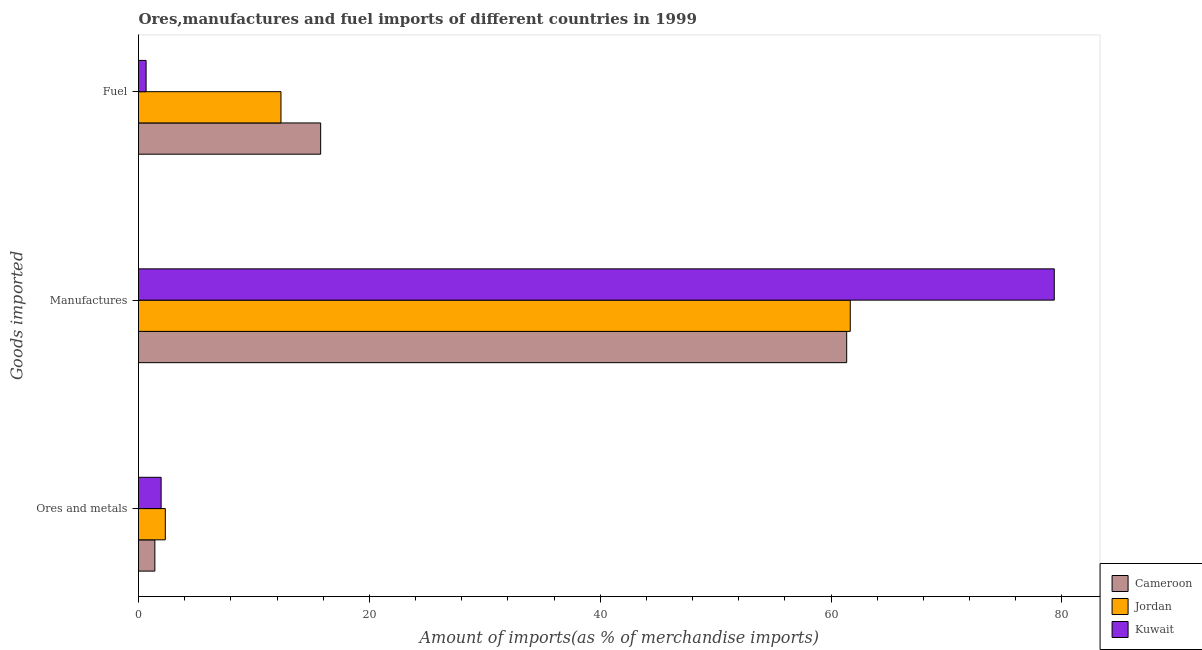How many different coloured bars are there?
Make the answer very short. 3. How many groups of bars are there?
Your answer should be compact. 3. Are the number of bars on each tick of the Y-axis equal?
Give a very brief answer. Yes. How many bars are there on the 3rd tick from the top?
Offer a terse response. 3. What is the label of the 1st group of bars from the top?
Your answer should be very brief. Fuel. What is the percentage of manufactures imports in Kuwait?
Your answer should be compact. 79.33. Across all countries, what is the maximum percentage of ores and metals imports?
Offer a very short reply. 2.32. Across all countries, what is the minimum percentage of fuel imports?
Your answer should be very brief. 0.66. In which country was the percentage of fuel imports maximum?
Your response must be concise. Cameroon. In which country was the percentage of ores and metals imports minimum?
Give a very brief answer. Cameroon. What is the total percentage of fuel imports in the graph?
Ensure brevity in your answer.  28.78. What is the difference between the percentage of manufactures imports in Cameroon and that in Kuwait?
Provide a short and direct response. -17.98. What is the difference between the percentage of manufactures imports in Cameroon and the percentage of fuel imports in Jordan?
Your answer should be compact. 49.01. What is the average percentage of ores and metals imports per country?
Your response must be concise. 1.9. What is the difference between the percentage of ores and metals imports and percentage of fuel imports in Cameroon?
Your answer should be compact. -14.36. In how many countries, is the percentage of fuel imports greater than 24 %?
Your answer should be very brief. 0. What is the ratio of the percentage of manufactures imports in Kuwait to that in Cameroon?
Your answer should be very brief. 1.29. Is the difference between the percentage of ores and metals imports in Jordan and Kuwait greater than the difference between the percentage of manufactures imports in Jordan and Kuwait?
Make the answer very short. Yes. What is the difference between the highest and the second highest percentage of manufactures imports?
Make the answer very short. 17.67. What is the difference between the highest and the lowest percentage of fuel imports?
Your response must be concise. 15.12. In how many countries, is the percentage of manufactures imports greater than the average percentage of manufactures imports taken over all countries?
Your answer should be very brief. 1. Is the sum of the percentage of fuel imports in Cameroon and Jordan greater than the maximum percentage of ores and metals imports across all countries?
Ensure brevity in your answer.  Yes. What does the 1st bar from the top in Manufactures represents?
Ensure brevity in your answer.  Kuwait. What does the 1st bar from the bottom in Ores and metals represents?
Your response must be concise. Cameroon. Does the graph contain any zero values?
Ensure brevity in your answer.  No. Where does the legend appear in the graph?
Ensure brevity in your answer.  Bottom right. How are the legend labels stacked?
Provide a succinct answer. Vertical. What is the title of the graph?
Offer a very short reply. Ores,manufactures and fuel imports of different countries in 1999. Does "Finland" appear as one of the legend labels in the graph?
Your response must be concise. No. What is the label or title of the X-axis?
Provide a short and direct response. Amount of imports(as % of merchandise imports). What is the label or title of the Y-axis?
Ensure brevity in your answer.  Goods imported. What is the Amount of imports(as % of merchandise imports) in Cameroon in Ores and metals?
Provide a succinct answer. 1.42. What is the Amount of imports(as % of merchandise imports) in Jordan in Ores and metals?
Give a very brief answer. 2.32. What is the Amount of imports(as % of merchandise imports) in Kuwait in Ores and metals?
Offer a very short reply. 1.96. What is the Amount of imports(as % of merchandise imports) in Cameroon in Manufactures?
Your answer should be compact. 61.35. What is the Amount of imports(as % of merchandise imports) in Jordan in Manufactures?
Offer a very short reply. 61.66. What is the Amount of imports(as % of merchandise imports) of Kuwait in Manufactures?
Make the answer very short. 79.33. What is the Amount of imports(as % of merchandise imports) of Cameroon in Fuel?
Provide a short and direct response. 15.78. What is the Amount of imports(as % of merchandise imports) of Jordan in Fuel?
Offer a very short reply. 12.34. What is the Amount of imports(as % of merchandise imports) in Kuwait in Fuel?
Make the answer very short. 0.66. Across all Goods imported, what is the maximum Amount of imports(as % of merchandise imports) in Cameroon?
Make the answer very short. 61.35. Across all Goods imported, what is the maximum Amount of imports(as % of merchandise imports) of Jordan?
Provide a short and direct response. 61.66. Across all Goods imported, what is the maximum Amount of imports(as % of merchandise imports) of Kuwait?
Your answer should be very brief. 79.33. Across all Goods imported, what is the minimum Amount of imports(as % of merchandise imports) in Cameroon?
Give a very brief answer. 1.42. Across all Goods imported, what is the minimum Amount of imports(as % of merchandise imports) of Jordan?
Provide a succinct answer. 2.32. Across all Goods imported, what is the minimum Amount of imports(as % of merchandise imports) of Kuwait?
Provide a short and direct response. 0.66. What is the total Amount of imports(as % of merchandise imports) in Cameroon in the graph?
Your answer should be very brief. 78.55. What is the total Amount of imports(as % of merchandise imports) of Jordan in the graph?
Ensure brevity in your answer.  76.33. What is the total Amount of imports(as % of merchandise imports) of Kuwait in the graph?
Give a very brief answer. 81.95. What is the difference between the Amount of imports(as % of merchandise imports) of Cameroon in Ores and metals and that in Manufactures?
Give a very brief answer. -59.93. What is the difference between the Amount of imports(as % of merchandise imports) in Jordan in Ores and metals and that in Manufactures?
Offer a very short reply. -59.34. What is the difference between the Amount of imports(as % of merchandise imports) of Kuwait in Ores and metals and that in Manufactures?
Your answer should be compact. -77.38. What is the difference between the Amount of imports(as % of merchandise imports) in Cameroon in Ores and metals and that in Fuel?
Ensure brevity in your answer.  -14.36. What is the difference between the Amount of imports(as % of merchandise imports) in Jordan in Ores and metals and that in Fuel?
Your answer should be very brief. -10.02. What is the difference between the Amount of imports(as % of merchandise imports) of Kuwait in Ores and metals and that in Fuel?
Your response must be concise. 1.3. What is the difference between the Amount of imports(as % of merchandise imports) in Cameroon in Manufactures and that in Fuel?
Offer a very short reply. 45.57. What is the difference between the Amount of imports(as % of merchandise imports) of Jordan in Manufactures and that in Fuel?
Ensure brevity in your answer.  49.32. What is the difference between the Amount of imports(as % of merchandise imports) of Kuwait in Manufactures and that in Fuel?
Your answer should be compact. 78.68. What is the difference between the Amount of imports(as % of merchandise imports) in Cameroon in Ores and metals and the Amount of imports(as % of merchandise imports) in Jordan in Manufactures?
Keep it short and to the point. -60.24. What is the difference between the Amount of imports(as % of merchandise imports) in Cameroon in Ores and metals and the Amount of imports(as % of merchandise imports) in Kuwait in Manufactures?
Provide a short and direct response. -77.92. What is the difference between the Amount of imports(as % of merchandise imports) of Jordan in Ores and metals and the Amount of imports(as % of merchandise imports) of Kuwait in Manufactures?
Your answer should be compact. -77.01. What is the difference between the Amount of imports(as % of merchandise imports) of Cameroon in Ores and metals and the Amount of imports(as % of merchandise imports) of Jordan in Fuel?
Ensure brevity in your answer.  -10.93. What is the difference between the Amount of imports(as % of merchandise imports) of Cameroon in Ores and metals and the Amount of imports(as % of merchandise imports) of Kuwait in Fuel?
Your answer should be compact. 0.76. What is the difference between the Amount of imports(as % of merchandise imports) in Jordan in Ores and metals and the Amount of imports(as % of merchandise imports) in Kuwait in Fuel?
Keep it short and to the point. 1.66. What is the difference between the Amount of imports(as % of merchandise imports) of Cameroon in Manufactures and the Amount of imports(as % of merchandise imports) of Jordan in Fuel?
Your answer should be compact. 49.01. What is the difference between the Amount of imports(as % of merchandise imports) of Cameroon in Manufactures and the Amount of imports(as % of merchandise imports) of Kuwait in Fuel?
Keep it short and to the point. 60.69. What is the difference between the Amount of imports(as % of merchandise imports) in Jordan in Manufactures and the Amount of imports(as % of merchandise imports) in Kuwait in Fuel?
Give a very brief answer. 61. What is the average Amount of imports(as % of merchandise imports) of Cameroon per Goods imported?
Make the answer very short. 26.18. What is the average Amount of imports(as % of merchandise imports) of Jordan per Goods imported?
Your answer should be compact. 25.44. What is the average Amount of imports(as % of merchandise imports) in Kuwait per Goods imported?
Offer a very short reply. 27.32. What is the difference between the Amount of imports(as % of merchandise imports) in Cameroon and Amount of imports(as % of merchandise imports) in Jordan in Ores and metals?
Offer a very short reply. -0.91. What is the difference between the Amount of imports(as % of merchandise imports) in Cameroon and Amount of imports(as % of merchandise imports) in Kuwait in Ores and metals?
Provide a succinct answer. -0.54. What is the difference between the Amount of imports(as % of merchandise imports) in Jordan and Amount of imports(as % of merchandise imports) in Kuwait in Ores and metals?
Give a very brief answer. 0.36. What is the difference between the Amount of imports(as % of merchandise imports) in Cameroon and Amount of imports(as % of merchandise imports) in Jordan in Manufactures?
Provide a short and direct response. -0.31. What is the difference between the Amount of imports(as % of merchandise imports) of Cameroon and Amount of imports(as % of merchandise imports) of Kuwait in Manufactures?
Ensure brevity in your answer.  -17.98. What is the difference between the Amount of imports(as % of merchandise imports) of Jordan and Amount of imports(as % of merchandise imports) of Kuwait in Manufactures?
Provide a succinct answer. -17.67. What is the difference between the Amount of imports(as % of merchandise imports) of Cameroon and Amount of imports(as % of merchandise imports) of Jordan in Fuel?
Provide a short and direct response. 3.44. What is the difference between the Amount of imports(as % of merchandise imports) in Cameroon and Amount of imports(as % of merchandise imports) in Kuwait in Fuel?
Offer a very short reply. 15.12. What is the difference between the Amount of imports(as % of merchandise imports) of Jordan and Amount of imports(as % of merchandise imports) of Kuwait in Fuel?
Make the answer very short. 11.68. What is the ratio of the Amount of imports(as % of merchandise imports) of Cameroon in Ores and metals to that in Manufactures?
Your response must be concise. 0.02. What is the ratio of the Amount of imports(as % of merchandise imports) in Jordan in Ores and metals to that in Manufactures?
Offer a very short reply. 0.04. What is the ratio of the Amount of imports(as % of merchandise imports) in Kuwait in Ores and metals to that in Manufactures?
Offer a very short reply. 0.02. What is the ratio of the Amount of imports(as % of merchandise imports) of Cameroon in Ores and metals to that in Fuel?
Make the answer very short. 0.09. What is the ratio of the Amount of imports(as % of merchandise imports) in Jordan in Ores and metals to that in Fuel?
Provide a short and direct response. 0.19. What is the ratio of the Amount of imports(as % of merchandise imports) of Kuwait in Ores and metals to that in Fuel?
Give a very brief answer. 2.98. What is the ratio of the Amount of imports(as % of merchandise imports) in Cameroon in Manufactures to that in Fuel?
Offer a terse response. 3.89. What is the ratio of the Amount of imports(as % of merchandise imports) of Jordan in Manufactures to that in Fuel?
Your answer should be compact. 5. What is the ratio of the Amount of imports(as % of merchandise imports) in Kuwait in Manufactures to that in Fuel?
Provide a succinct answer. 120.69. What is the difference between the highest and the second highest Amount of imports(as % of merchandise imports) in Cameroon?
Your response must be concise. 45.57. What is the difference between the highest and the second highest Amount of imports(as % of merchandise imports) of Jordan?
Your answer should be compact. 49.32. What is the difference between the highest and the second highest Amount of imports(as % of merchandise imports) in Kuwait?
Your response must be concise. 77.38. What is the difference between the highest and the lowest Amount of imports(as % of merchandise imports) of Cameroon?
Make the answer very short. 59.93. What is the difference between the highest and the lowest Amount of imports(as % of merchandise imports) in Jordan?
Your answer should be compact. 59.34. What is the difference between the highest and the lowest Amount of imports(as % of merchandise imports) of Kuwait?
Provide a succinct answer. 78.68. 